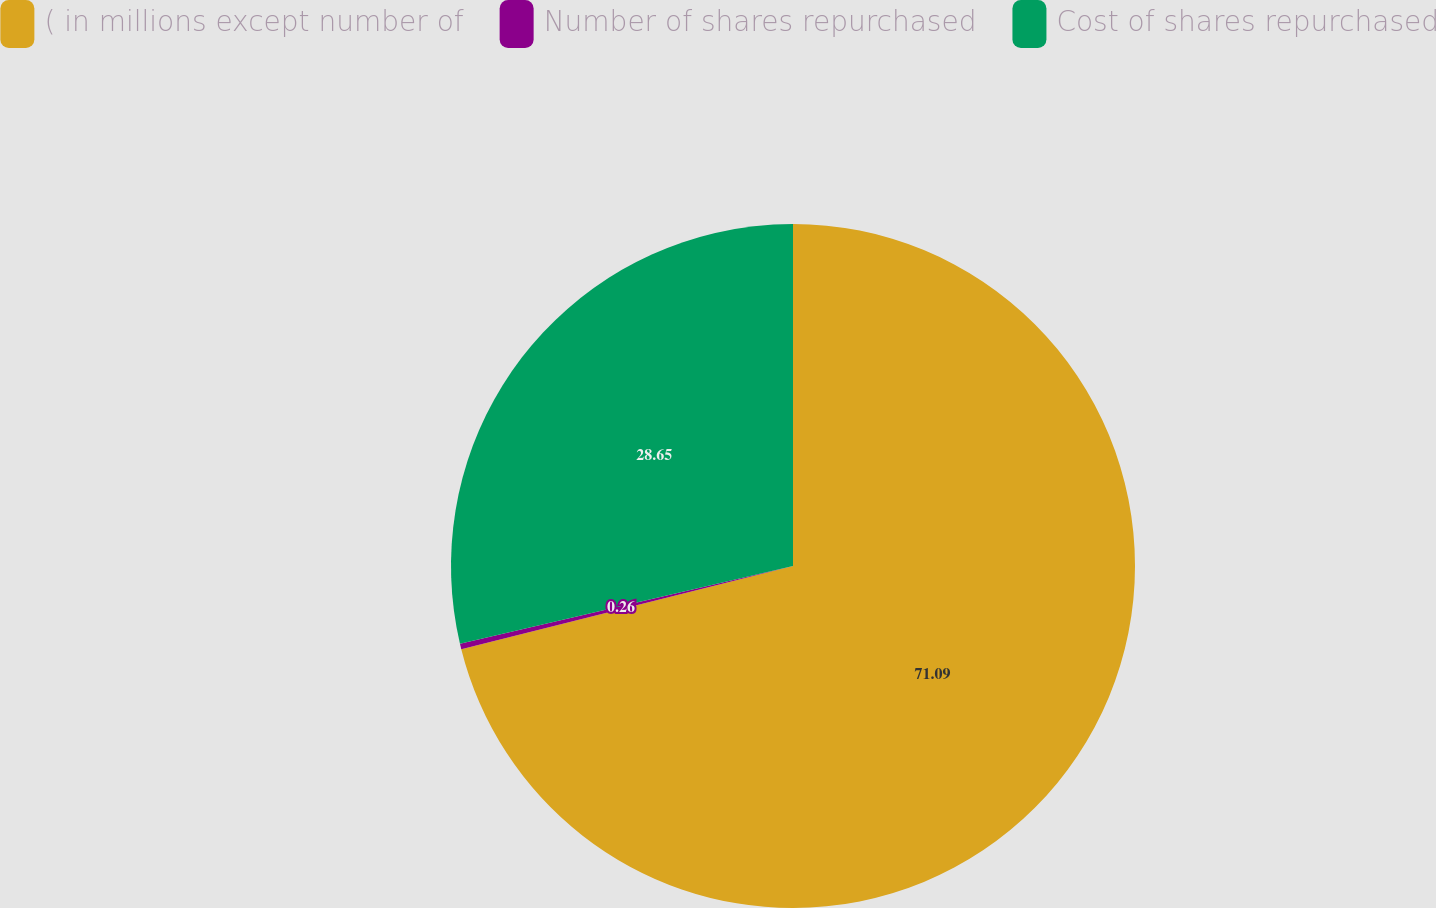<chart> <loc_0><loc_0><loc_500><loc_500><pie_chart><fcel>( in millions except number of<fcel>Number of shares repurchased<fcel>Cost of shares repurchased<nl><fcel>71.09%<fcel>0.26%<fcel>28.65%<nl></chart> 